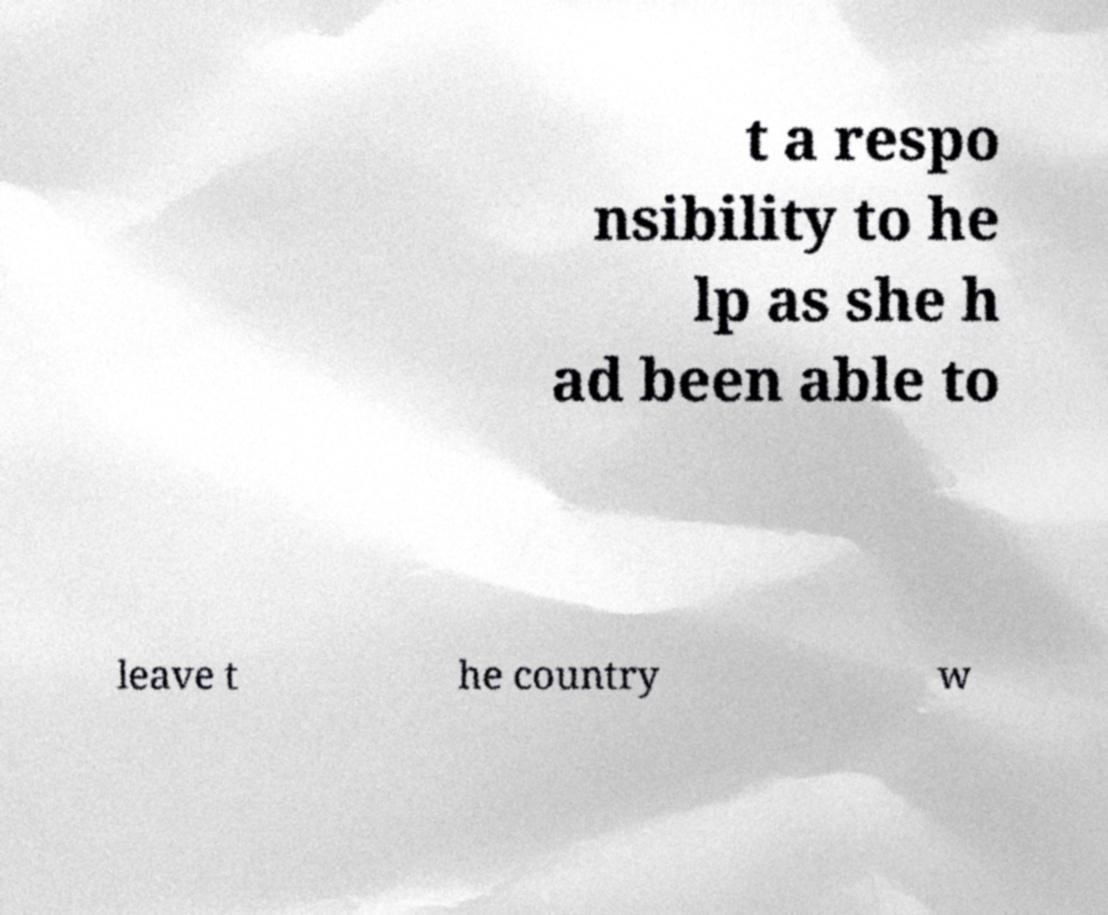For documentation purposes, I need the text within this image transcribed. Could you provide that? t a respo nsibility to he lp as she h ad been able to leave t he country w 